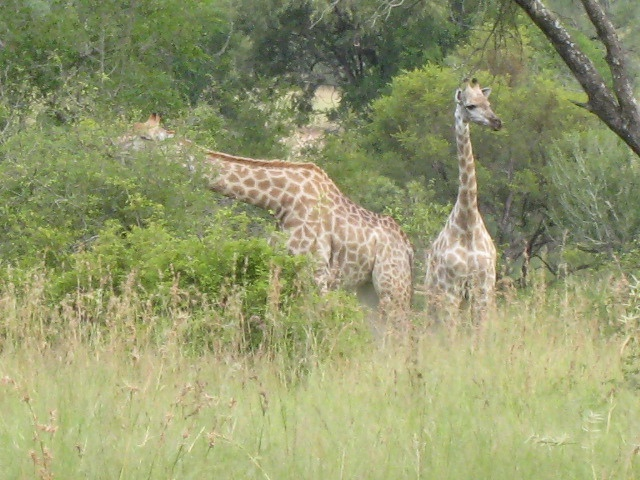Describe the objects in this image and their specific colors. I can see giraffe in gray and tan tones and giraffe in gray, darkgray, and tan tones in this image. 